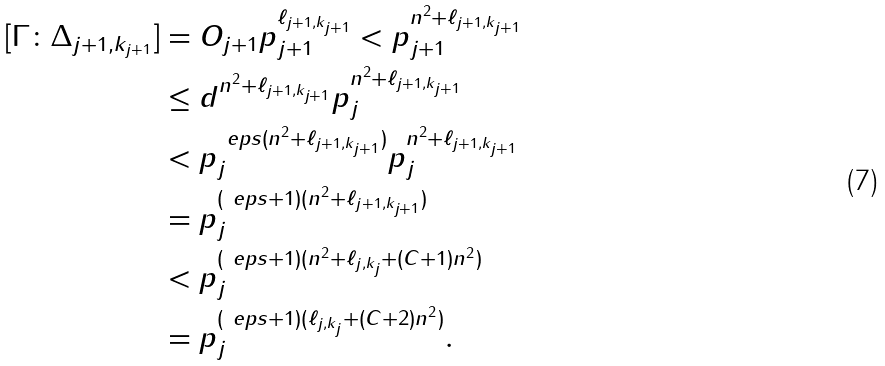Convert formula to latex. <formula><loc_0><loc_0><loc_500><loc_500>[ \Gamma \colon \Delta _ { j + 1 , k _ { j + 1 } } ] & = O _ { j + 1 } p _ { j + 1 } ^ { \ell _ { j + 1 , k _ { j + 1 } } } < p _ { j + 1 } ^ { n ^ { 2 } + \ell _ { j + 1 , k _ { j + 1 } } } \\ & \leq d ^ { n ^ { 2 } + \ell _ { j + 1 , k _ { j + 1 } } } p _ { j } ^ { n ^ { 2 } + \ell _ { j + 1 , k _ { j + 1 } } } \\ & < p _ { j } ^ { \ e p s ( n ^ { 2 } + \ell _ { j + 1 , k _ { j + 1 } } ) } p _ { j } ^ { n ^ { 2 } + \ell _ { j + 1 , k _ { j + 1 } } } \\ & = p _ { j } ^ { ( \ e p s + 1 ) ( n ^ { 2 } + \ell _ { j + 1 , k _ { j + 1 } } ) } \\ & < p _ { j } ^ { ( \ e p s + 1 ) ( n ^ { 2 } + \ell _ { j , k _ { j } } + ( C + 1 ) n ^ { 2 } ) } \\ & = p _ { j } ^ { ( \ e p s + 1 ) ( \ell _ { j , k _ { j } } + ( C + 2 ) n ^ { 2 } ) } .</formula> 